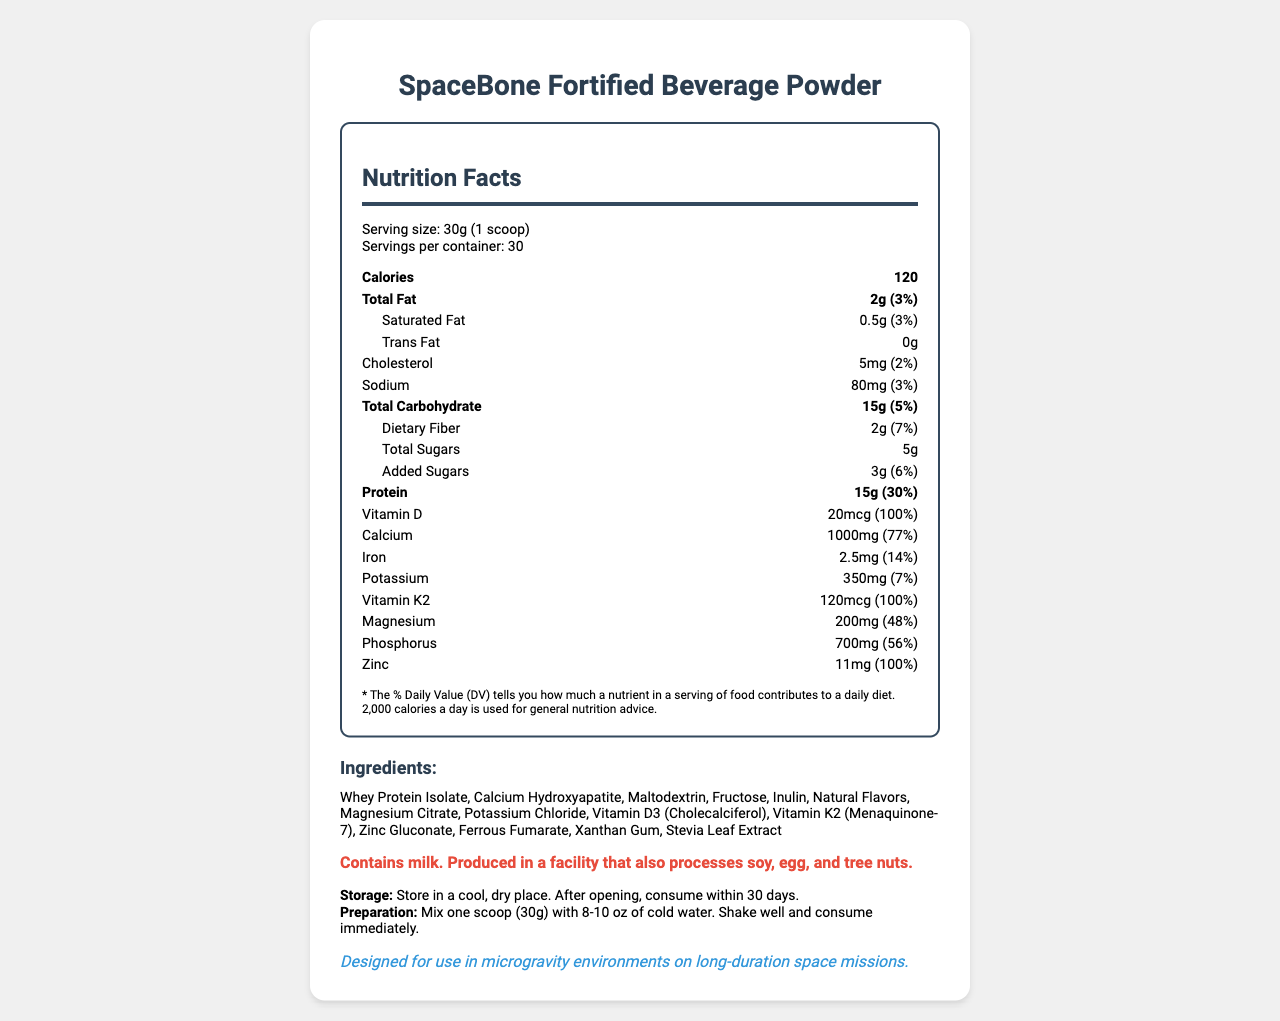Who is the manufacturer of the SpaceBone Fortified Beverage Powder? The document mentions, "manufacturerInfo," where it lists the manufacturer's name as AstroNutrition Labs.
Answer: AstroNutrition Labs What is the serving size of the beverage powder? The serving size is stated under the serving info section as "30g (1 scoop)."
Answer: 30g (1 scoop) How many servings per container are available for this product? The serving info section indicates there are "30" servings per container.
Answer: 30 What is the amount of calcium per serving? Under the nutrient breakdown, it states "Calcium: 1000mg".
Answer: 1000mg What is the percent daily value of vitamin D per serving? The document specifies under vitamin D that it provides "100% of the daily value."
Answer: 100% What is the total carbohydrate content per serving, and what percent of the daily value does it provide? The document shows "Total Carbohydrate: 15g (5%)" under the nutrient data.
Answer: 15g, 5% What are the allergens mentioned in the allergen warning? The allergen warning section of the document mentions these specifics.
Answer: Contains milk. Produced in a facility that also processes soy, egg, and tree nuts. How much protein does one serving of the drink provide? The nutrition facts section states that each serving contains "15g" of protein.
Answer: 15g What are the storage instructions for this beverage powder? This information is listed under the "storageInstructions" section.
Answer: Store in a cool, dry place. After opening, consume within 30 days. What is the mission compatibility of the product? This is detailed in the mission info section.
Answer: Designed for use in microgravity environments on long-duration space missions. When should the product be consumed before it expires? A. By December 2024 B. By June 2025 C. By March 2024 D. By January 2026 The expiration date listed is "2025-06-15," which corresponds to June 2025.
Answer: B. By June 2025 How much cholesterol is in one serving and what percent of the daily value is it? A. 0mg, 0% B. 5mg, 2% C. 10mg, 5% D. 20mg, 8% The nutrition facts section shows "Cholesterol: 5mg (2%)."
Answer: B. 5mg, 2% Does the product contain any trans fat? The document states "Trans Fat: 0g" in the nutrition facts section.
Answer: No Is this product suitable for vegans? The allergens note the product contains milk, making it unsuitable for a vegan diet.
Answer: No Summarize the purpose and main contents of this document. This summary covers all the key sections including the main product details, nutritional information, special instructions, and additional notes relevant to the product.
Answer: The document is a Nutrition Facts Label for the SpaceBone Fortified Beverage Powder, which is designed to combat bone density loss in microgravity environments. It includes information about serving size, nutrient content per serving, ingredients, allergen warnings, storage, and preparation instructions, as well as manufacturer and mission compatibility details. What type of research collaboration is mentioned in the document? The research notes section states this specific collaboration detail.
Answer: Developed in collaboration with NASA's Advanced Food Technology Project and the International Space Station Human Research Program. What is the exact location of the manufacturer? The document provides this address under manufacturerInfo.
Answer: 1000 Space Center Blvd, Houston, TX 77058 What studies have shown the effectiveness of this product in combating bone density loss in microgravity? The document mentions the product is designed for this purpose, but it does not provide any specific studies or detailed research evidence.
Answer: Not enough information What is the contact phone number for the manufacturer? The manufacturer's contact phone number is listed under the manufacturerInfo section.
Answer: +1 (800) 555-SPACE 